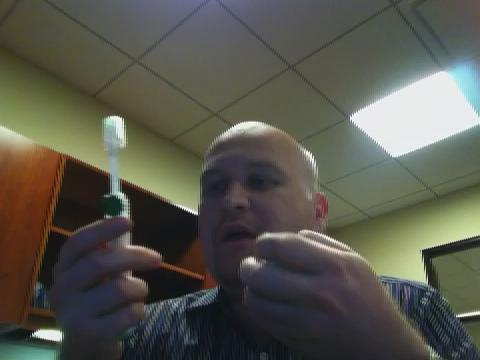Is the guy holding a toothbrush?
Concise answer only. Yes. Is the man bald?
Short answer required. Yes. Can the man turn around and see his reflection?
Short answer required. Yes. 